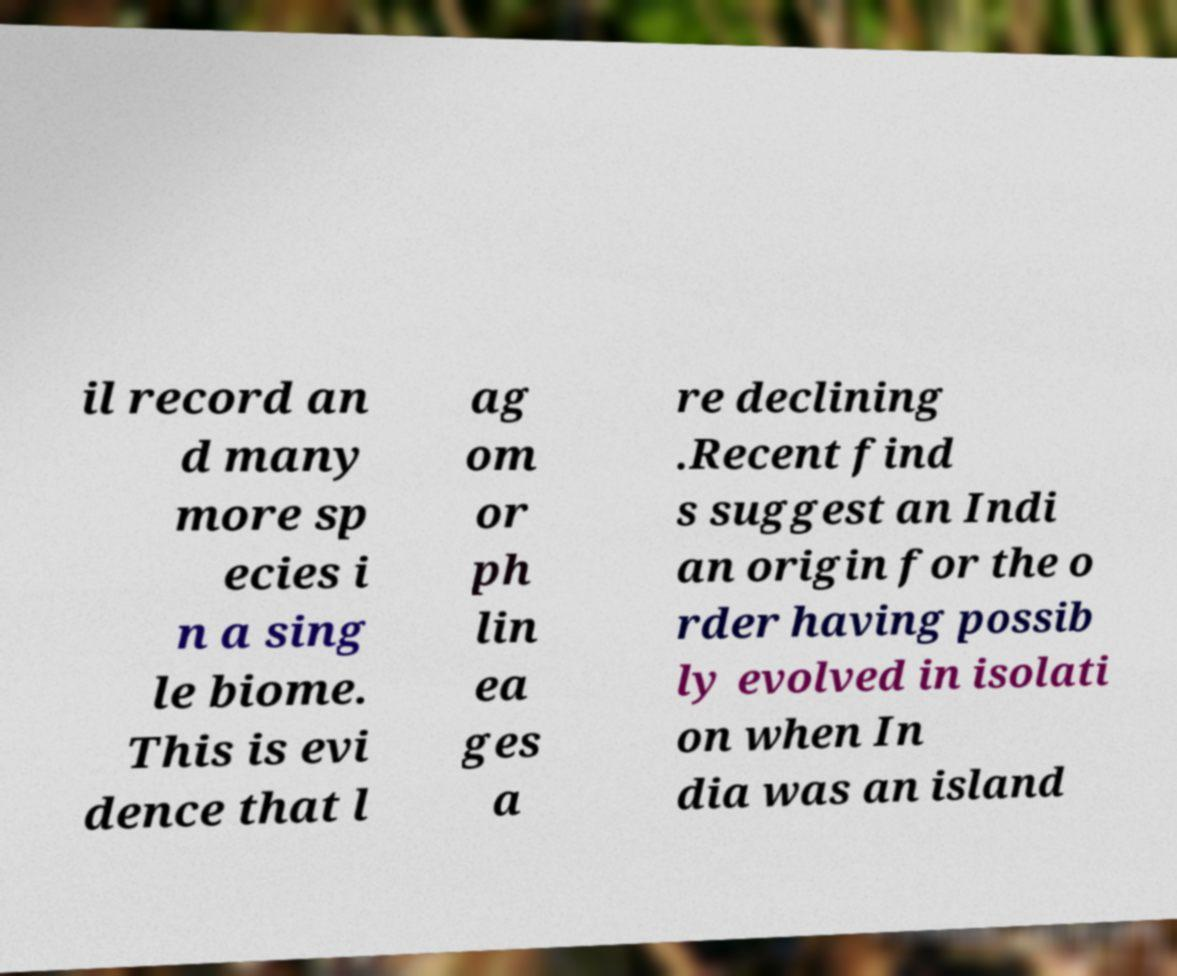There's text embedded in this image that I need extracted. Can you transcribe it verbatim? il record an d many more sp ecies i n a sing le biome. This is evi dence that l ag om or ph lin ea ges a re declining .Recent find s suggest an Indi an origin for the o rder having possib ly evolved in isolati on when In dia was an island 